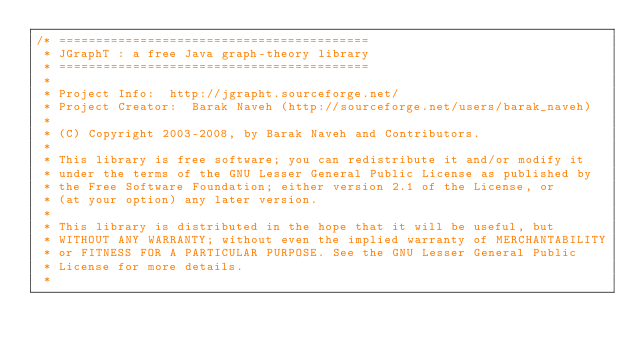<code> <loc_0><loc_0><loc_500><loc_500><_Java_>/* ==========================================
 * JGraphT : a free Java graph-theory library
 * ==========================================
 *
 * Project Info:  http://jgrapht.sourceforge.net/
 * Project Creator:  Barak Naveh (http://sourceforge.net/users/barak_naveh)
 *
 * (C) Copyright 2003-2008, by Barak Naveh and Contributors.
 *
 * This library is free software; you can redistribute it and/or modify it
 * under the terms of the GNU Lesser General Public License as published by
 * the Free Software Foundation; either version 2.1 of the License, or
 * (at your option) any later version.
 *
 * This library is distributed in the hope that it will be useful, but
 * WITHOUT ANY WARRANTY; without even the implied warranty of MERCHANTABILITY
 * or FITNESS FOR A PARTICULAR PURPOSE. See the GNU Lesser General Public
 * License for more details.
 *</code> 